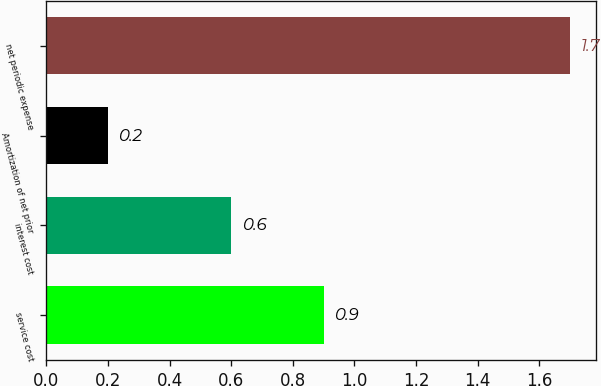Convert chart to OTSL. <chart><loc_0><loc_0><loc_500><loc_500><bar_chart><fcel>service cost<fcel>interest cost<fcel>Amortization of net prior<fcel>net periodic expense<nl><fcel>0.9<fcel>0.6<fcel>0.2<fcel>1.7<nl></chart> 